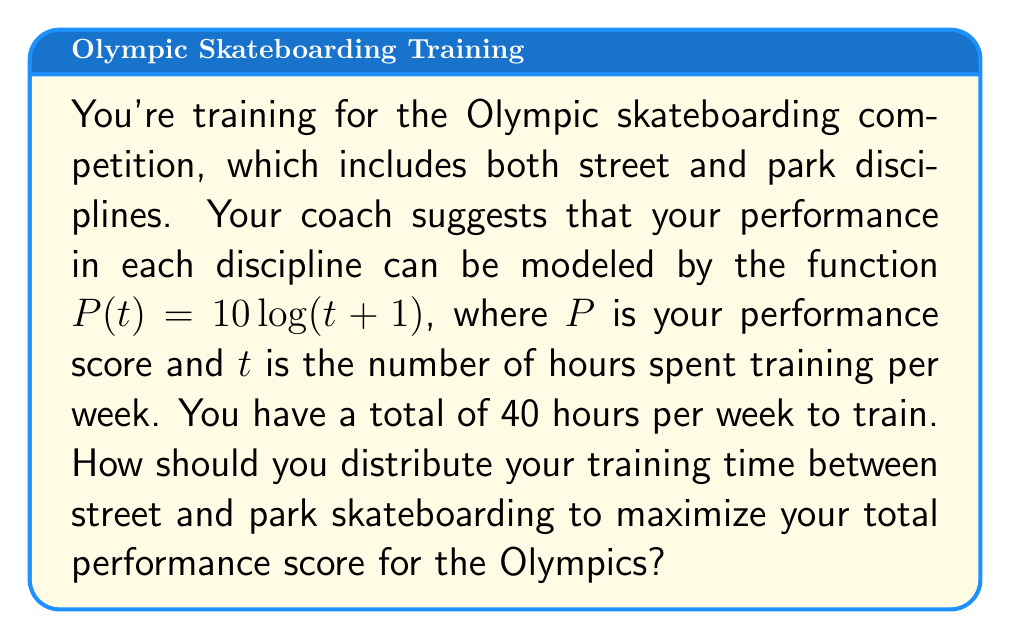Can you answer this question? Let's approach this step-by-step using game theory and optimization:

1) Let $x$ be the number of hours spent training for street skateboarding, and $40-x$ be the hours for park skateboarding (since the total is 40 hours).

2) The total performance score $S$ is the sum of both disciplines:

   $S(x) = P(x) + P(40-x) = 10\log(x+1) + 10\log((40-x)+1)$

3) To maximize $S(x)$, we need to find where its derivative equals zero:

   $\frac{dS}{dx} = \frac{10}{x+1} - \frac{10}{41-x} = 0$

4) Solving this equation:

   $\frac{10}{x+1} = \frac{10}{41-x}$
   $41-x = x+1$
   $40 = 2x$
   $x = 20$

5) We can confirm this is a maximum by checking the second derivative is negative:

   $\frac{d^2S}{dx^2} = -\frac{10}{(x+1)^2} - \frac{10}{(41-x)^2} < 0$ for all $x$ between 0 and 40.

6) Therefore, the optimal strategy is to spend 20 hours on street skateboarding and 20 hours on park skateboarding.

7) The maximum total score is:

   $S(20) = 10\log(21) + 10\log(21) = 20\log(21) \approx 61.07$
Answer: The optimal distribution is 20 hours for street skateboarding and 20 hours for park skateboarding, resulting in a maximum total performance score of approximately 61.07. 